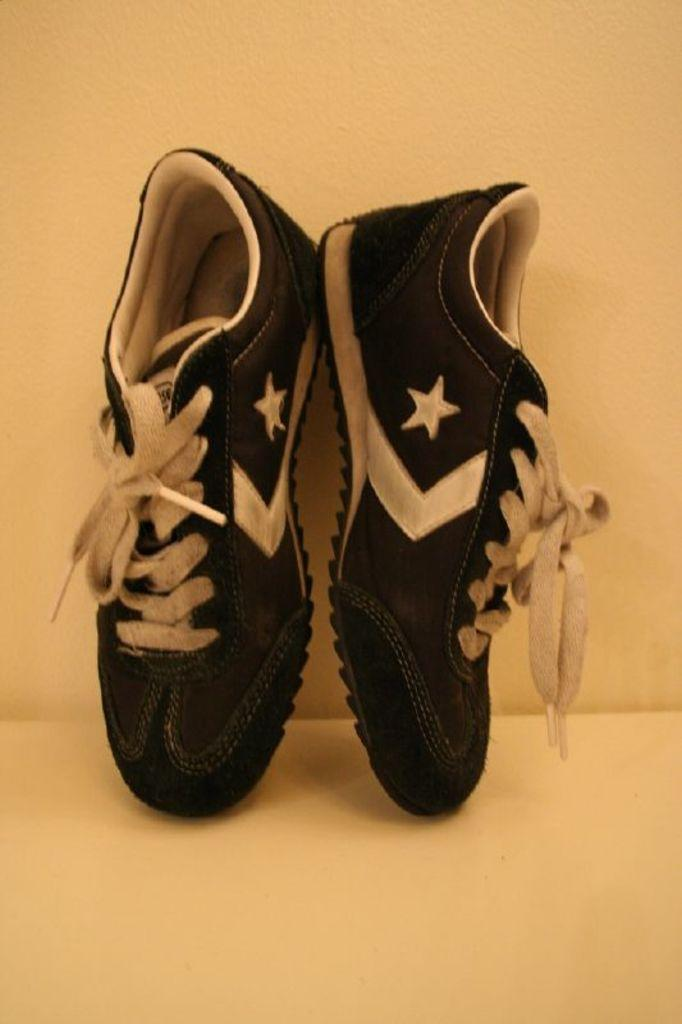What color are the shoes in the image? The shoes in the image are black. What color are the shoelaces on the shoes? The shoelaces on the shoes are white. What color is the wall in the background of the image? The wall in the background of the image is yellow. What type of amusement can be seen on the property in the image? There is no amusement or property present in the image; it only features black shoes with white shoelaces against a yellow wall background. 